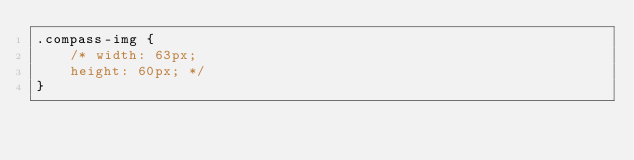<code> <loc_0><loc_0><loc_500><loc_500><_CSS_>.compass-img {
    /* width: 63px;
    height: 60px; */
}</code> 